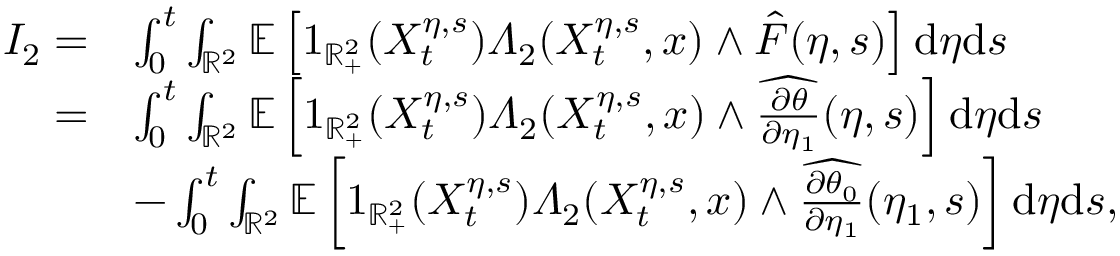Convert formula to latex. <formula><loc_0><loc_0><loc_500><loc_500>\begin{array} { r l } { I _ { 2 } = } & { \int _ { 0 } ^ { t } \int _ { \mathbb { R } ^ { 2 } } \mathbb { E } \left [ 1 _ { \mathbb { R } _ { + } ^ { 2 } } ( X _ { t } ^ { \eta , s } ) \varLambda _ { 2 } ( X _ { t } ^ { \eta , s } , x ) \wedge \hat { F } ( \eta , s ) \right ] d \eta d s } \\ { = } & { \int _ { 0 } ^ { t } \int _ { \mathbb { R } ^ { 2 } } \mathbb { E } \left [ 1 _ { \mathbb { R } _ { + } ^ { 2 } } ( X _ { t } ^ { \eta , s } ) \varLambda _ { 2 } ( X _ { t } ^ { \eta , s } , x ) \wedge \widehat { \frac { \partial \theta } { \partial \eta _ { 1 } } } ( \eta , s ) \right ] d \eta d s } \\ & { - \int _ { 0 } ^ { t } \int _ { \mathbb { R } ^ { 2 } } \mathbb { E } \left [ 1 _ { \mathbb { R } _ { + } ^ { 2 } } ( X _ { t } ^ { \eta , s } ) \varLambda _ { 2 } ( X _ { t } ^ { \eta , s } , x ) \wedge \widehat { \frac { \partial \theta _ { 0 } } { \partial \eta _ { 1 } } } ( \eta _ { 1 } , s ) \right ] d \eta d s , } \end{array}</formula> 